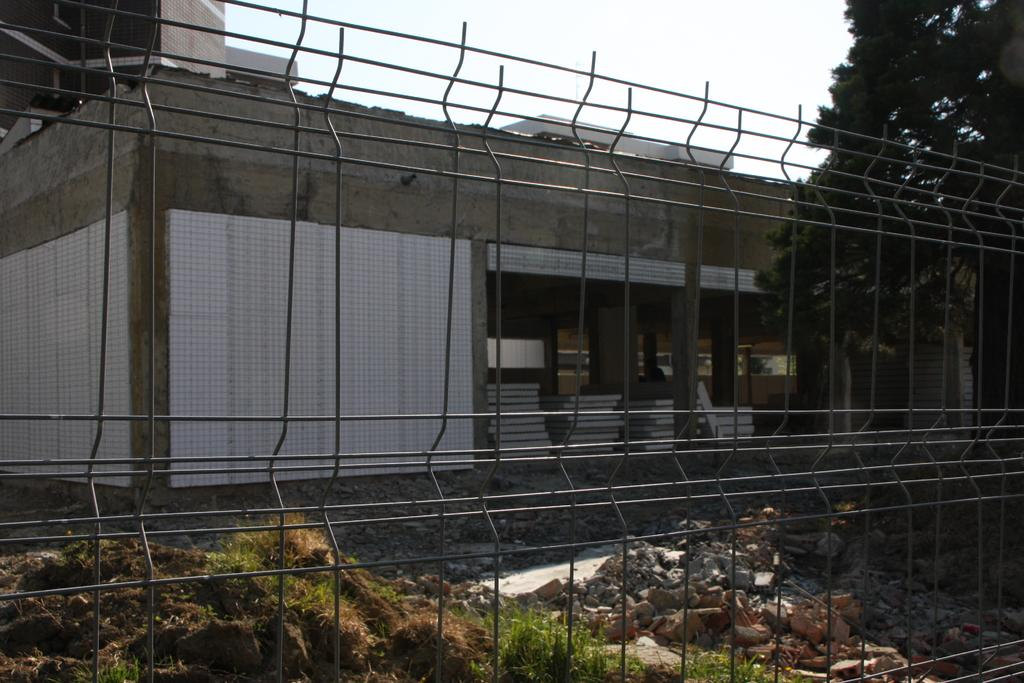What is the main subject in the center of the image? There is a fencing in the center of the image. What can be seen at the bottom of the image? There are stones at the bottom of the image. What type of structure is visible in the image? There is a house in the image. What type of vegetation is in the background of the image? There is a tree in the background of the image. How many beginner fencers are running towards the house in the image? There are no people or fencers visible in the image, so it is not possible to determine the number of beginner fencers running towards the house. 